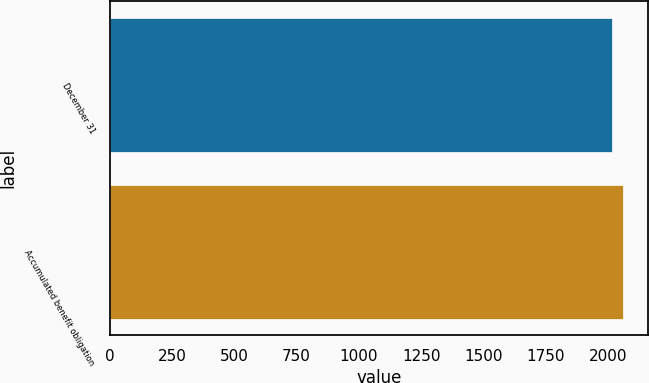Convert chart. <chart><loc_0><loc_0><loc_500><loc_500><bar_chart><fcel>December 31<fcel>Accumulated benefit obligation<nl><fcel>2014<fcel>2059<nl></chart> 